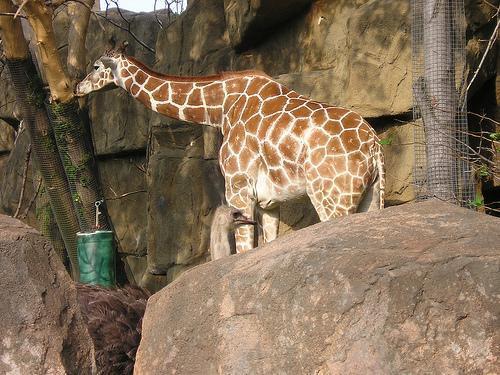How many animals do you see?
Give a very brief answer. 2. 